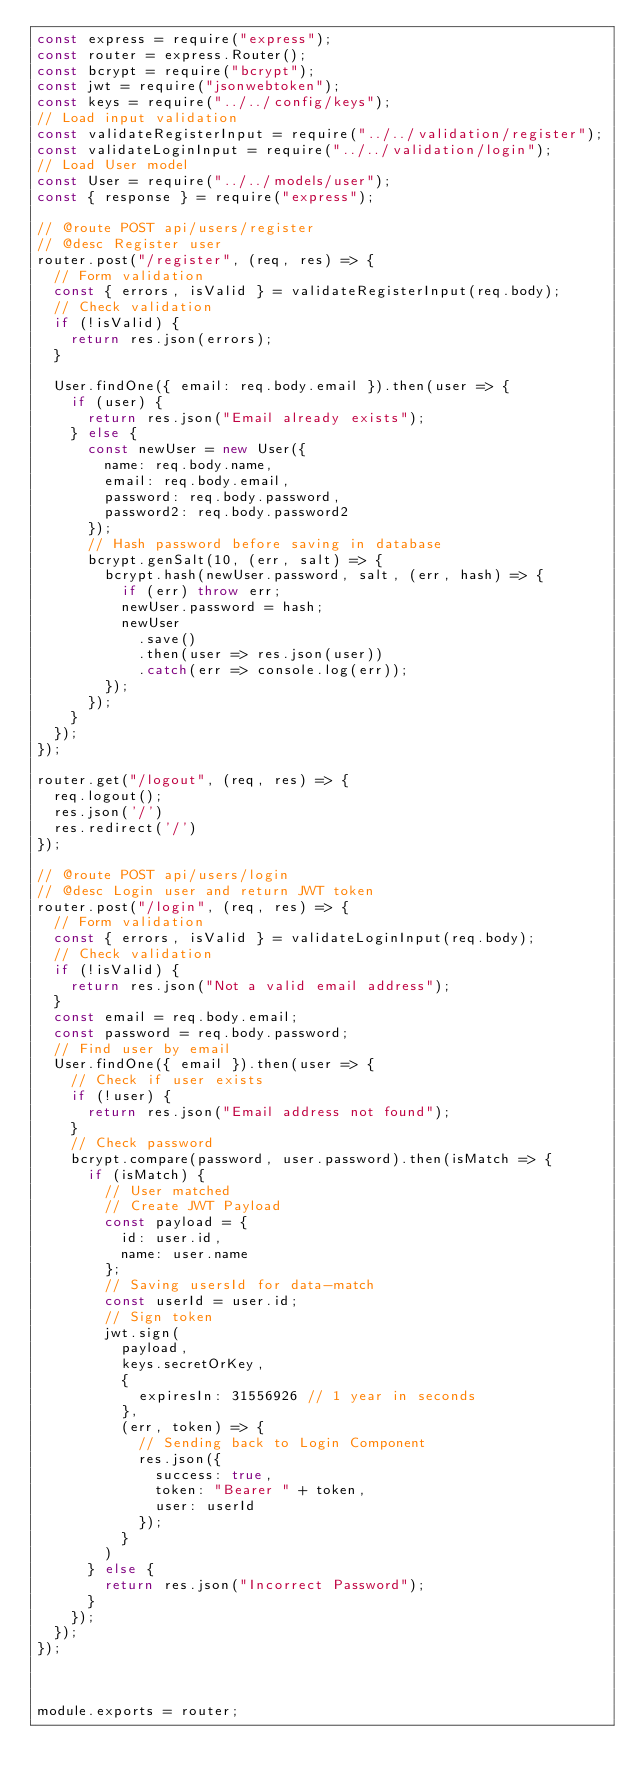<code> <loc_0><loc_0><loc_500><loc_500><_JavaScript_>const express = require("express");
const router = express.Router();
const bcrypt = require("bcrypt");
const jwt = require("jsonwebtoken");
const keys = require("../../config/keys");
// Load input validation
const validateRegisterInput = require("../../validation/register");
const validateLoginInput = require("../../validation/login");
// Load User model
const User = require("../../models/user");
const { response } = require("express");

// @route POST api/users/register
// @desc Register user
router.post("/register", (req, res) => {
  // Form validation
  const { errors, isValid } = validateRegisterInput(req.body);
  // Check validation
  if (!isValid) {
    return res.json(errors);
  }

  User.findOne({ email: req.body.email }).then(user => {
    if (user) {
      return res.json("Email already exists");
    } else {
      const newUser = new User({
        name: req.body.name,
        email: req.body.email,
        password: req.body.password,
        password2: req.body.password2
      });
      // Hash password before saving in database
      bcrypt.genSalt(10, (err, salt) => {
        bcrypt.hash(newUser.password, salt, (err, hash) => {
          if (err) throw err;
          newUser.password = hash;
          newUser
            .save()
            .then(user => res.json(user))
            .catch(err => console.log(err));
        });
      });
    }
  });
});

router.get("/logout", (req, res) => {
  req.logout();
  res.json('/')
  res.redirect('/')
});

// @route POST api/users/login
// @desc Login user and return JWT token
router.post("/login", (req, res) => {
  // Form validation
  const { errors, isValid } = validateLoginInput(req.body);
  // Check validation
  if (!isValid) {
    return res.json("Not a valid email address");
  }
  const email = req.body.email;
  const password = req.body.password;
  // Find user by email
  User.findOne({ email }).then(user => {
    // Check if user exists
    if (!user) {
      return res.json("Email address not found");
    }
    // Check password
    bcrypt.compare(password, user.password).then(isMatch => {
      if (isMatch) {
        // User matched
        // Create JWT Payload
        const payload = {
          id: user.id,
          name: user.name
        };
        // Saving usersId for data-match
        const userId = user.id;
        // Sign token
        jwt.sign(
          payload,
          keys.secretOrKey,
          {
            expiresIn: 31556926 // 1 year in seconds
          },
          (err, token) => {
            // Sending back to Login Component
            res.json({
              success: true,
              token: "Bearer " + token,
              user: userId
            });
          }
        )
      } else {
        return res.json("Incorrect Password");
      }
    });
  });
});



module.exports = router;
</code> 